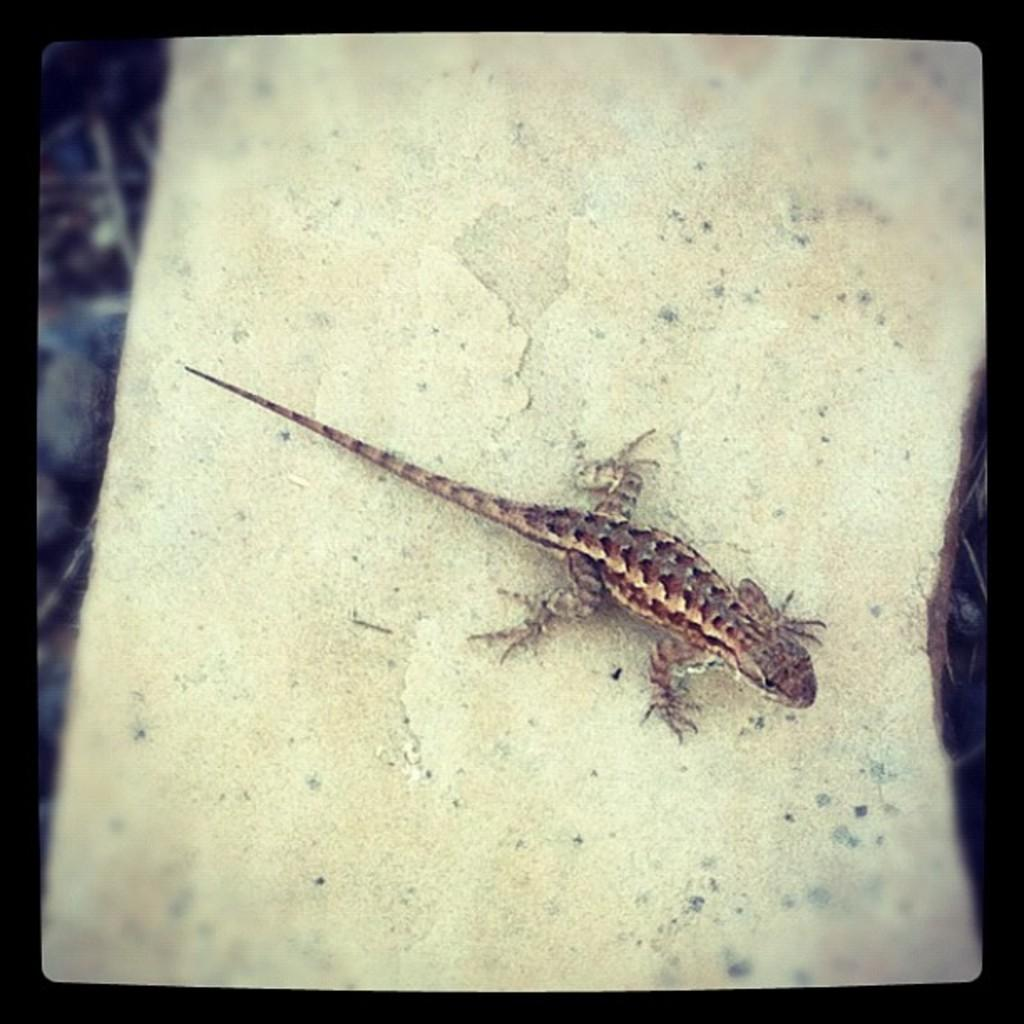What type of animal is in the picture? There is a lizard in the picture. Where is the lizard located in the image? The lizard is on a surface. Can you describe the background of the image? The background of the image is blurry. How many jellyfish can be seen swimming in the background of the image? There are no jellyfish present in the image; the background is blurry. 